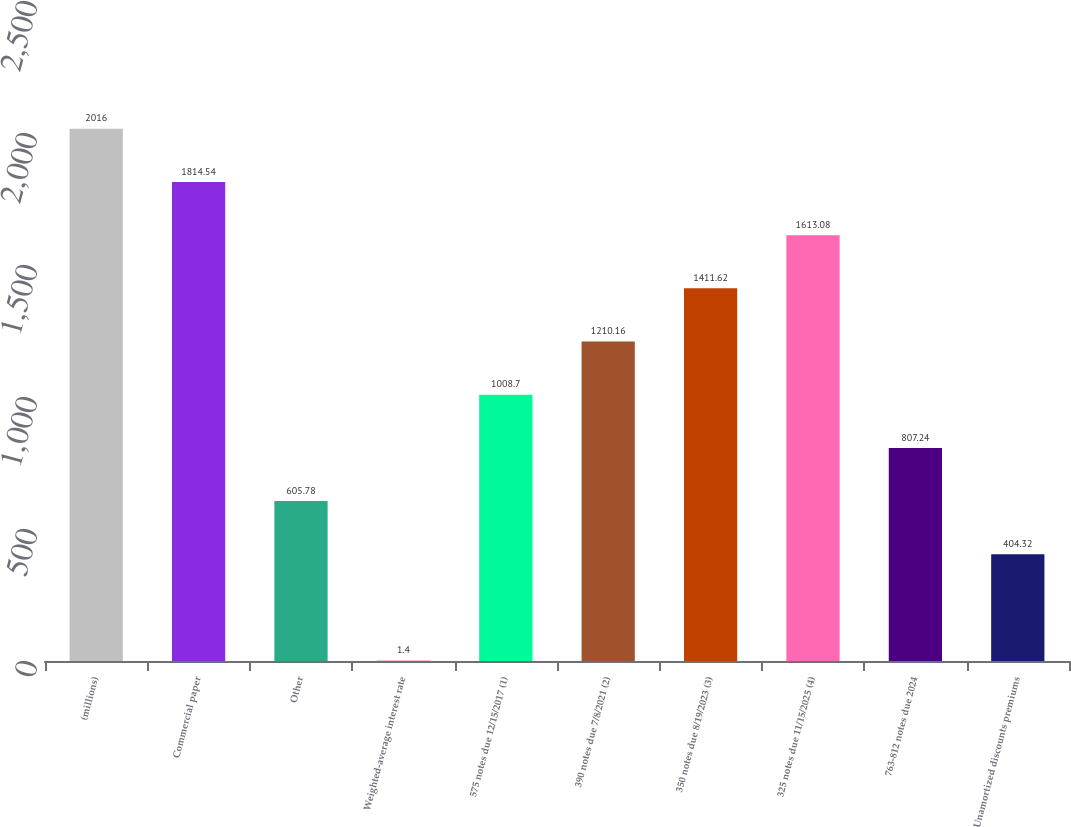Convert chart to OTSL. <chart><loc_0><loc_0><loc_500><loc_500><bar_chart><fcel>(millions)<fcel>Commercial paper<fcel>Other<fcel>Weighted-average interest rate<fcel>575 notes due 12/15/2017 (1)<fcel>390 notes due 7/8/2021 (2)<fcel>350 notes due 8/19/2023 (3)<fcel>325 notes due 11/15/2025 (4)<fcel>763-812 notes due 2024<fcel>Unamortized discounts premiums<nl><fcel>2016<fcel>1814.54<fcel>605.78<fcel>1.4<fcel>1008.7<fcel>1210.16<fcel>1411.62<fcel>1613.08<fcel>807.24<fcel>404.32<nl></chart> 